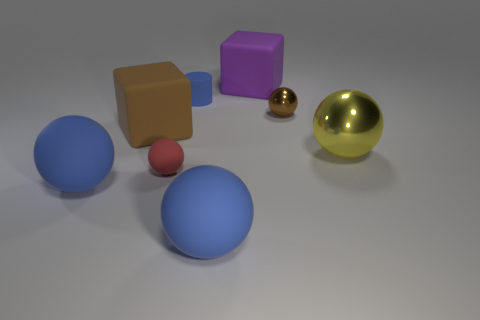There is a blue matte thing that is the same size as the brown metal thing; what shape is it?
Make the answer very short. Cylinder. What number of big things are either matte cubes or brown balls?
Your response must be concise. 2. There is a yellow thing that is on the right side of the large rubber cube that is in front of the small cylinder; is there a big yellow ball behind it?
Offer a terse response. No. Is there a brown block that has the same size as the red sphere?
Your answer should be very brief. No. What is the material of the yellow ball that is the same size as the brown block?
Provide a short and direct response. Metal. There is a yellow sphere; is its size the same as the cube behind the small cylinder?
Offer a very short reply. Yes. How many rubber things are big blue balls or large yellow things?
Your answer should be very brief. 2. How many other metal objects have the same shape as the tiny brown object?
Provide a succinct answer. 1. What material is the block that is the same color as the small metal sphere?
Ensure brevity in your answer.  Rubber. Is the size of the cube left of the large purple rubber thing the same as the shiny sphere behind the yellow ball?
Give a very brief answer. No. 